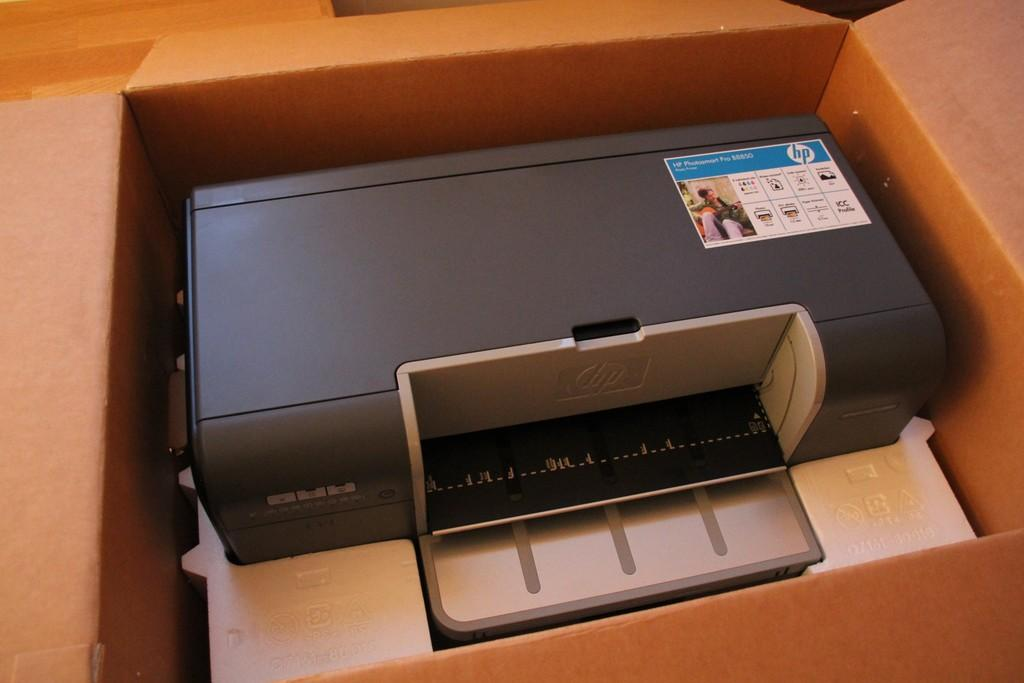<image>
Render a clear and concise summary of the photo. Black printer modeled 88850 still in a brown box. 